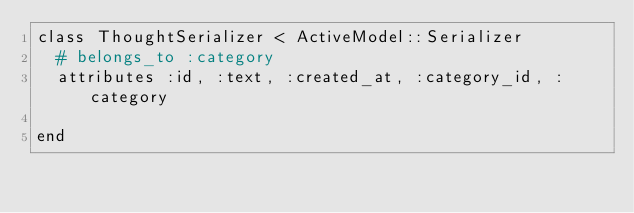Convert code to text. <code><loc_0><loc_0><loc_500><loc_500><_Ruby_>class ThoughtSerializer < ActiveModel::Serializer
  # belongs_to :category
  attributes :id, :text, :created_at, :category_id, :category

end
</code> 